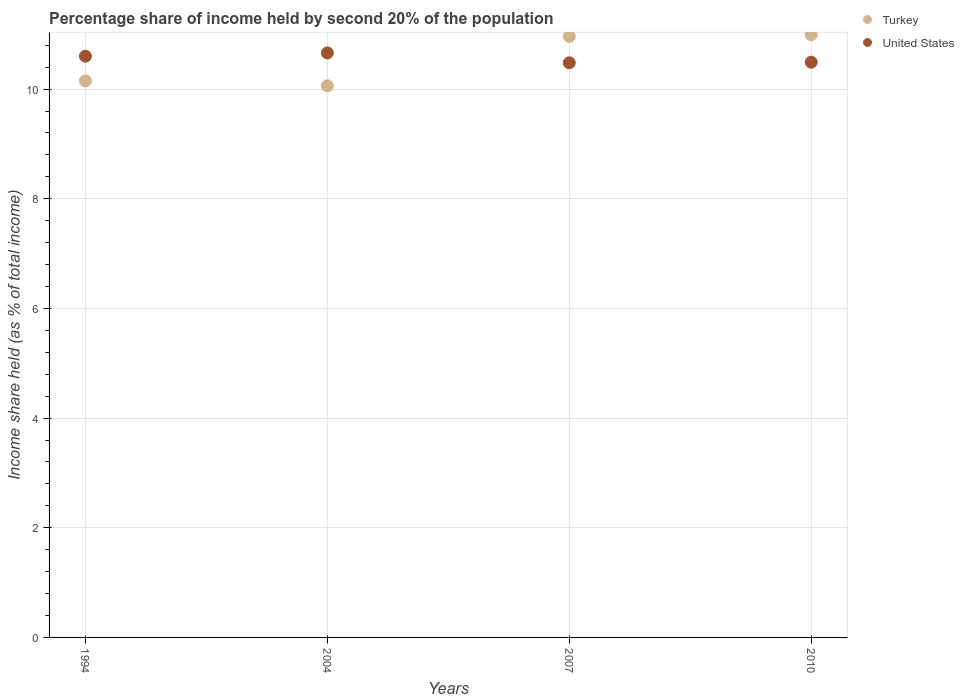Is the number of dotlines equal to the number of legend labels?
Provide a short and direct response. Yes. What is the share of income held by second 20% of the population in United States in 2007?
Your response must be concise. 10.48. Across all years, what is the maximum share of income held by second 20% of the population in United States?
Ensure brevity in your answer.  10.66. Across all years, what is the minimum share of income held by second 20% of the population in United States?
Offer a very short reply. 10.48. In which year was the share of income held by second 20% of the population in United States minimum?
Provide a succinct answer. 2007. What is the total share of income held by second 20% of the population in Turkey in the graph?
Your response must be concise. 42.16. What is the difference between the share of income held by second 20% of the population in United States in 1994 and that in 2010?
Make the answer very short. 0.11. What is the difference between the share of income held by second 20% of the population in United States in 1994 and the share of income held by second 20% of the population in Turkey in 2010?
Offer a very short reply. -0.39. What is the average share of income held by second 20% of the population in United States per year?
Offer a terse response. 10.56. In the year 2004, what is the difference between the share of income held by second 20% of the population in United States and share of income held by second 20% of the population in Turkey?
Make the answer very short. 0.6. What is the ratio of the share of income held by second 20% of the population in Turkey in 2007 to that in 2010?
Your answer should be very brief. 1. Is the difference between the share of income held by second 20% of the population in United States in 2004 and 2010 greater than the difference between the share of income held by second 20% of the population in Turkey in 2004 and 2010?
Provide a succinct answer. Yes. What is the difference between the highest and the second highest share of income held by second 20% of the population in Turkey?
Your answer should be very brief. 0.03. What is the difference between the highest and the lowest share of income held by second 20% of the population in Turkey?
Keep it short and to the point. 0.93. In how many years, is the share of income held by second 20% of the population in Turkey greater than the average share of income held by second 20% of the population in Turkey taken over all years?
Your answer should be compact. 2. Does the share of income held by second 20% of the population in Turkey monotonically increase over the years?
Your answer should be compact. No. Is the share of income held by second 20% of the population in United States strictly greater than the share of income held by second 20% of the population in Turkey over the years?
Keep it short and to the point. No. Is the share of income held by second 20% of the population in United States strictly less than the share of income held by second 20% of the population in Turkey over the years?
Give a very brief answer. No. How many dotlines are there?
Provide a short and direct response. 2. How many years are there in the graph?
Offer a terse response. 4. What is the difference between two consecutive major ticks on the Y-axis?
Keep it short and to the point. 2. Are the values on the major ticks of Y-axis written in scientific E-notation?
Provide a succinct answer. No. Does the graph contain any zero values?
Ensure brevity in your answer.  No. Does the graph contain grids?
Provide a short and direct response. Yes. What is the title of the graph?
Keep it short and to the point. Percentage share of income held by second 20% of the population. What is the label or title of the X-axis?
Offer a very short reply. Years. What is the label or title of the Y-axis?
Your answer should be very brief. Income share held (as % of total income). What is the Income share held (as % of total income) of Turkey in 1994?
Provide a succinct answer. 10.15. What is the Income share held (as % of total income) of United States in 1994?
Offer a terse response. 10.6. What is the Income share held (as % of total income) of Turkey in 2004?
Provide a succinct answer. 10.06. What is the Income share held (as % of total income) in United States in 2004?
Make the answer very short. 10.66. What is the Income share held (as % of total income) of Turkey in 2007?
Offer a terse response. 10.96. What is the Income share held (as % of total income) of United States in 2007?
Your response must be concise. 10.48. What is the Income share held (as % of total income) of Turkey in 2010?
Your answer should be very brief. 10.99. What is the Income share held (as % of total income) in United States in 2010?
Give a very brief answer. 10.49. Across all years, what is the maximum Income share held (as % of total income) of Turkey?
Your answer should be compact. 10.99. Across all years, what is the maximum Income share held (as % of total income) of United States?
Make the answer very short. 10.66. Across all years, what is the minimum Income share held (as % of total income) of Turkey?
Offer a terse response. 10.06. Across all years, what is the minimum Income share held (as % of total income) of United States?
Your answer should be very brief. 10.48. What is the total Income share held (as % of total income) of Turkey in the graph?
Your answer should be very brief. 42.16. What is the total Income share held (as % of total income) in United States in the graph?
Provide a succinct answer. 42.23. What is the difference between the Income share held (as % of total income) in Turkey in 1994 and that in 2004?
Ensure brevity in your answer.  0.09. What is the difference between the Income share held (as % of total income) of United States in 1994 and that in 2004?
Your answer should be compact. -0.06. What is the difference between the Income share held (as % of total income) of Turkey in 1994 and that in 2007?
Ensure brevity in your answer.  -0.81. What is the difference between the Income share held (as % of total income) of United States in 1994 and that in 2007?
Offer a terse response. 0.12. What is the difference between the Income share held (as % of total income) of Turkey in 1994 and that in 2010?
Your response must be concise. -0.84. What is the difference between the Income share held (as % of total income) in United States in 1994 and that in 2010?
Keep it short and to the point. 0.11. What is the difference between the Income share held (as % of total income) of Turkey in 2004 and that in 2007?
Keep it short and to the point. -0.9. What is the difference between the Income share held (as % of total income) of United States in 2004 and that in 2007?
Provide a short and direct response. 0.18. What is the difference between the Income share held (as % of total income) in Turkey in 2004 and that in 2010?
Offer a terse response. -0.93. What is the difference between the Income share held (as % of total income) of United States in 2004 and that in 2010?
Your answer should be compact. 0.17. What is the difference between the Income share held (as % of total income) of Turkey in 2007 and that in 2010?
Provide a succinct answer. -0.03. What is the difference between the Income share held (as % of total income) in United States in 2007 and that in 2010?
Your answer should be very brief. -0.01. What is the difference between the Income share held (as % of total income) in Turkey in 1994 and the Income share held (as % of total income) in United States in 2004?
Ensure brevity in your answer.  -0.51. What is the difference between the Income share held (as % of total income) of Turkey in 1994 and the Income share held (as % of total income) of United States in 2007?
Ensure brevity in your answer.  -0.33. What is the difference between the Income share held (as % of total income) in Turkey in 1994 and the Income share held (as % of total income) in United States in 2010?
Ensure brevity in your answer.  -0.34. What is the difference between the Income share held (as % of total income) in Turkey in 2004 and the Income share held (as % of total income) in United States in 2007?
Ensure brevity in your answer.  -0.42. What is the difference between the Income share held (as % of total income) of Turkey in 2004 and the Income share held (as % of total income) of United States in 2010?
Provide a short and direct response. -0.43. What is the difference between the Income share held (as % of total income) of Turkey in 2007 and the Income share held (as % of total income) of United States in 2010?
Provide a short and direct response. 0.47. What is the average Income share held (as % of total income) of Turkey per year?
Your response must be concise. 10.54. What is the average Income share held (as % of total income) in United States per year?
Provide a short and direct response. 10.56. In the year 1994, what is the difference between the Income share held (as % of total income) in Turkey and Income share held (as % of total income) in United States?
Offer a very short reply. -0.45. In the year 2004, what is the difference between the Income share held (as % of total income) of Turkey and Income share held (as % of total income) of United States?
Your response must be concise. -0.6. In the year 2007, what is the difference between the Income share held (as % of total income) of Turkey and Income share held (as % of total income) of United States?
Your response must be concise. 0.48. What is the ratio of the Income share held (as % of total income) of Turkey in 1994 to that in 2004?
Ensure brevity in your answer.  1.01. What is the ratio of the Income share held (as % of total income) in United States in 1994 to that in 2004?
Ensure brevity in your answer.  0.99. What is the ratio of the Income share held (as % of total income) of Turkey in 1994 to that in 2007?
Your answer should be very brief. 0.93. What is the ratio of the Income share held (as % of total income) of United States in 1994 to that in 2007?
Your answer should be compact. 1.01. What is the ratio of the Income share held (as % of total income) of Turkey in 1994 to that in 2010?
Keep it short and to the point. 0.92. What is the ratio of the Income share held (as % of total income) in United States in 1994 to that in 2010?
Offer a terse response. 1.01. What is the ratio of the Income share held (as % of total income) of Turkey in 2004 to that in 2007?
Your response must be concise. 0.92. What is the ratio of the Income share held (as % of total income) in United States in 2004 to that in 2007?
Provide a short and direct response. 1.02. What is the ratio of the Income share held (as % of total income) in Turkey in 2004 to that in 2010?
Your answer should be compact. 0.92. What is the ratio of the Income share held (as % of total income) of United States in 2004 to that in 2010?
Keep it short and to the point. 1.02. What is the ratio of the Income share held (as % of total income) in Turkey in 2007 to that in 2010?
Offer a very short reply. 1. What is the ratio of the Income share held (as % of total income) of United States in 2007 to that in 2010?
Provide a short and direct response. 1. What is the difference between the highest and the second highest Income share held (as % of total income) of Turkey?
Keep it short and to the point. 0.03. What is the difference between the highest and the lowest Income share held (as % of total income) in Turkey?
Your response must be concise. 0.93. What is the difference between the highest and the lowest Income share held (as % of total income) of United States?
Your answer should be compact. 0.18. 